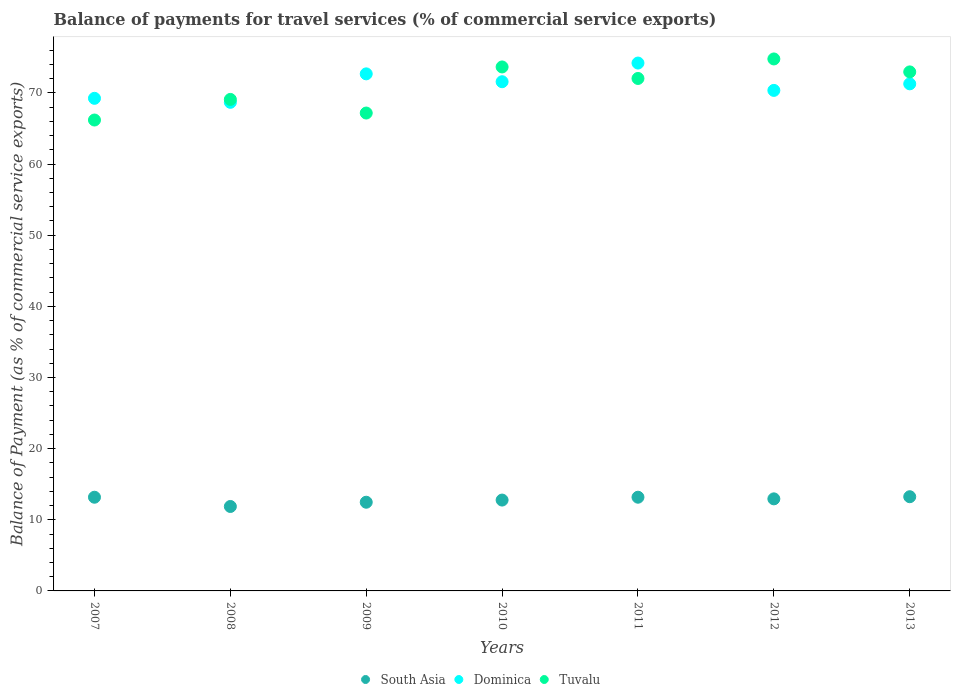How many different coloured dotlines are there?
Offer a very short reply. 3. Is the number of dotlines equal to the number of legend labels?
Offer a very short reply. Yes. What is the balance of payments for travel services in Tuvalu in 2010?
Offer a very short reply. 73.65. Across all years, what is the maximum balance of payments for travel services in South Asia?
Give a very brief answer. 13.24. Across all years, what is the minimum balance of payments for travel services in Tuvalu?
Keep it short and to the point. 66.19. In which year was the balance of payments for travel services in South Asia maximum?
Your answer should be compact. 2013. What is the total balance of payments for travel services in Tuvalu in the graph?
Give a very brief answer. 495.86. What is the difference between the balance of payments for travel services in South Asia in 2009 and that in 2013?
Make the answer very short. -0.77. What is the difference between the balance of payments for travel services in Dominica in 2013 and the balance of payments for travel services in Tuvalu in 2009?
Provide a succinct answer. 4.1. What is the average balance of payments for travel services in South Asia per year?
Offer a very short reply. 12.8. In the year 2013, what is the difference between the balance of payments for travel services in South Asia and balance of payments for travel services in Tuvalu?
Your response must be concise. -59.71. What is the ratio of the balance of payments for travel services in South Asia in 2009 to that in 2012?
Offer a terse response. 0.96. Is the balance of payments for travel services in Dominica in 2008 less than that in 2009?
Keep it short and to the point. Yes. What is the difference between the highest and the second highest balance of payments for travel services in South Asia?
Provide a succinct answer. 0.07. What is the difference between the highest and the lowest balance of payments for travel services in South Asia?
Provide a succinct answer. 1.37. Is the sum of the balance of payments for travel services in Tuvalu in 2008 and 2009 greater than the maximum balance of payments for travel services in South Asia across all years?
Your response must be concise. Yes. Is it the case that in every year, the sum of the balance of payments for travel services in Tuvalu and balance of payments for travel services in Dominica  is greater than the balance of payments for travel services in South Asia?
Provide a short and direct response. Yes. Does the balance of payments for travel services in Dominica monotonically increase over the years?
Your response must be concise. No. How many years are there in the graph?
Provide a short and direct response. 7. Are the values on the major ticks of Y-axis written in scientific E-notation?
Provide a short and direct response. No. How many legend labels are there?
Provide a short and direct response. 3. How are the legend labels stacked?
Provide a short and direct response. Horizontal. What is the title of the graph?
Your response must be concise. Balance of payments for travel services (% of commercial service exports). Does "Fragile and conflict affected situations" appear as one of the legend labels in the graph?
Provide a short and direct response. No. What is the label or title of the Y-axis?
Offer a very short reply. Balance of Payment (as % of commercial service exports). What is the Balance of Payment (as % of commercial service exports) of South Asia in 2007?
Ensure brevity in your answer.  13.17. What is the Balance of Payment (as % of commercial service exports) of Dominica in 2007?
Your answer should be compact. 69.24. What is the Balance of Payment (as % of commercial service exports) of Tuvalu in 2007?
Offer a very short reply. 66.19. What is the Balance of Payment (as % of commercial service exports) of South Asia in 2008?
Ensure brevity in your answer.  11.87. What is the Balance of Payment (as % of commercial service exports) in Dominica in 2008?
Your answer should be very brief. 68.68. What is the Balance of Payment (as % of commercial service exports) in Tuvalu in 2008?
Your response must be concise. 69.09. What is the Balance of Payment (as % of commercial service exports) in South Asia in 2009?
Ensure brevity in your answer.  12.47. What is the Balance of Payment (as % of commercial service exports) in Dominica in 2009?
Your answer should be very brief. 72.68. What is the Balance of Payment (as % of commercial service exports) of Tuvalu in 2009?
Ensure brevity in your answer.  67.17. What is the Balance of Payment (as % of commercial service exports) of South Asia in 2010?
Make the answer very short. 12.77. What is the Balance of Payment (as % of commercial service exports) in Dominica in 2010?
Make the answer very short. 71.57. What is the Balance of Payment (as % of commercial service exports) in Tuvalu in 2010?
Keep it short and to the point. 73.65. What is the Balance of Payment (as % of commercial service exports) of South Asia in 2011?
Provide a short and direct response. 13.17. What is the Balance of Payment (as % of commercial service exports) of Dominica in 2011?
Provide a succinct answer. 74.2. What is the Balance of Payment (as % of commercial service exports) of Tuvalu in 2011?
Provide a succinct answer. 72.03. What is the Balance of Payment (as % of commercial service exports) in South Asia in 2012?
Provide a succinct answer. 12.94. What is the Balance of Payment (as % of commercial service exports) of Dominica in 2012?
Your response must be concise. 70.36. What is the Balance of Payment (as % of commercial service exports) of Tuvalu in 2012?
Ensure brevity in your answer.  74.77. What is the Balance of Payment (as % of commercial service exports) in South Asia in 2013?
Your answer should be very brief. 13.24. What is the Balance of Payment (as % of commercial service exports) of Dominica in 2013?
Offer a terse response. 71.28. What is the Balance of Payment (as % of commercial service exports) of Tuvalu in 2013?
Your answer should be compact. 72.96. Across all years, what is the maximum Balance of Payment (as % of commercial service exports) in South Asia?
Provide a short and direct response. 13.24. Across all years, what is the maximum Balance of Payment (as % of commercial service exports) of Dominica?
Your answer should be very brief. 74.2. Across all years, what is the maximum Balance of Payment (as % of commercial service exports) in Tuvalu?
Your response must be concise. 74.77. Across all years, what is the minimum Balance of Payment (as % of commercial service exports) in South Asia?
Provide a succinct answer. 11.87. Across all years, what is the minimum Balance of Payment (as % of commercial service exports) in Dominica?
Keep it short and to the point. 68.68. Across all years, what is the minimum Balance of Payment (as % of commercial service exports) in Tuvalu?
Keep it short and to the point. 66.19. What is the total Balance of Payment (as % of commercial service exports) in South Asia in the graph?
Provide a short and direct response. 89.63. What is the total Balance of Payment (as % of commercial service exports) of Dominica in the graph?
Provide a short and direct response. 498. What is the total Balance of Payment (as % of commercial service exports) of Tuvalu in the graph?
Provide a succinct answer. 495.86. What is the difference between the Balance of Payment (as % of commercial service exports) of South Asia in 2007 and that in 2008?
Ensure brevity in your answer.  1.3. What is the difference between the Balance of Payment (as % of commercial service exports) of Dominica in 2007 and that in 2008?
Ensure brevity in your answer.  0.56. What is the difference between the Balance of Payment (as % of commercial service exports) of Tuvalu in 2007 and that in 2008?
Offer a terse response. -2.9. What is the difference between the Balance of Payment (as % of commercial service exports) in South Asia in 2007 and that in 2009?
Your answer should be compact. 0.7. What is the difference between the Balance of Payment (as % of commercial service exports) of Dominica in 2007 and that in 2009?
Ensure brevity in your answer.  -3.44. What is the difference between the Balance of Payment (as % of commercial service exports) of Tuvalu in 2007 and that in 2009?
Give a very brief answer. -0.98. What is the difference between the Balance of Payment (as % of commercial service exports) in South Asia in 2007 and that in 2010?
Make the answer very short. 0.4. What is the difference between the Balance of Payment (as % of commercial service exports) in Dominica in 2007 and that in 2010?
Your answer should be very brief. -2.33. What is the difference between the Balance of Payment (as % of commercial service exports) of Tuvalu in 2007 and that in 2010?
Provide a succinct answer. -7.46. What is the difference between the Balance of Payment (as % of commercial service exports) in South Asia in 2007 and that in 2011?
Make the answer very short. -0. What is the difference between the Balance of Payment (as % of commercial service exports) of Dominica in 2007 and that in 2011?
Your answer should be very brief. -4.96. What is the difference between the Balance of Payment (as % of commercial service exports) in Tuvalu in 2007 and that in 2011?
Give a very brief answer. -5.84. What is the difference between the Balance of Payment (as % of commercial service exports) of South Asia in 2007 and that in 2012?
Your answer should be very brief. 0.23. What is the difference between the Balance of Payment (as % of commercial service exports) in Dominica in 2007 and that in 2012?
Give a very brief answer. -1.11. What is the difference between the Balance of Payment (as % of commercial service exports) of Tuvalu in 2007 and that in 2012?
Make the answer very short. -8.58. What is the difference between the Balance of Payment (as % of commercial service exports) of South Asia in 2007 and that in 2013?
Your response must be concise. -0.07. What is the difference between the Balance of Payment (as % of commercial service exports) in Dominica in 2007 and that in 2013?
Keep it short and to the point. -2.04. What is the difference between the Balance of Payment (as % of commercial service exports) in Tuvalu in 2007 and that in 2013?
Provide a short and direct response. -6.77. What is the difference between the Balance of Payment (as % of commercial service exports) in South Asia in 2008 and that in 2009?
Keep it short and to the point. -0.6. What is the difference between the Balance of Payment (as % of commercial service exports) of Dominica in 2008 and that in 2009?
Ensure brevity in your answer.  -4. What is the difference between the Balance of Payment (as % of commercial service exports) of Tuvalu in 2008 and that in 2009?
Keep it short and to the point. 1.92. What is the difference between the Balance of Payment (as % of commercial service exports) of South Asia in 2008 and that in 2010?
Your response must be concise. -0.9. What is the difference between the Balance of Payment (as % of commercial service exports) of Dominica in 2008 and that in 2010?
Your response must be concise. -2.9. What is the difference between the Balance of Payment (as % of commercial service exports) in Tuvalu in 2008 and that in 2010?
Provide a succinct answer. -4.56. What is the difference between the Balance of Payment (as % of commercial service exports) in South Asia in 2008 and that in 2011?
Your answer should be compact. -1.3. What is the difference between the Balance of Payment (as % of commercial service exports) of Dominica in 2008 and that in 2011?
Provide a succinct answer. -5.52. What is the difference between the Balance of Payment (as % of commercial service exports) in Tuvalu in 2008 and that in 2011?
Offer a terse response. -2.95. What is the difference between the Balance of Payment (as % of commercial service exports) in South Asia in 2008 and that in 2012?
Your response must be concise. -1.07. What is the difference between the Balance of Payment (as % of commercial service exports) in Dominica in 2008 and that in 2012?
Provide a short and direct response. -1.68. What is the difference between the Balance of Payment (as % of commercial service exports) in Tuvalu in 2008 and that in 2012?
Give a very brief answer. -5.69. What is the difference between the Balance of Payment (as % of commercial service exports) of South Asia in 2008 and that in 2013?
Make the answer very short. -1.37. What is the difference between the Balance of Payment (as % of commercial service exports) of Dominica in 2008 and that in 2013?
Ensure brevity in your answer.  -2.6. What is the difference between the Balance of Payment (as % of commercial service exports) of Tuvalu in 2008 and that in 2013?
Give a very brief answer. -3.87. What is the difference between the Balance of Payment (as % of commercial service exports) in South Asia in 2009 and that in 2010?
Provide a short and direct response. -0.3. What is the difference between the Balance of Payment (as % of commercial service exports) in Dominica in 2009 and that in 2010?
Provide a succinct answer. 1.1. What is the difference between the Balance of Payment (as % of commercial service exports) in Tuvalu in 2009 and that in 2010?
Provide a succinct answer. -6.48. What is the difference between the Balance of Payment (as % of commercial service exports) of South Asia in 2009 and that in 2011?
Provide a short and direct response. -0.7. What is the difference between the Balance of Payment (as % of commercial service exports) of Dominica in 2009 and that in 2011?
Offer a terse response. -1.52. What is the difference between the Balance of Payment (as % of commercial service exports) in Tuvalu in 2009 and that in 2011?
Keep it short and to the point. -4.86. What is the difference between the Balance of Payment (as % of commercial service exports) in South Asia in 2009 and that in 2012?
Offer a terse response. -0.47. What is the difference between the Balance of Payment (as % of commercial service exports) of Dominica in 2009 and that in 2012?
Your answer should be very brief. 2.32. What is the difference between the Balance of Payment (as % of commercial service exports) of Tuvalu in 2009 and that in 2012?
Provide a succinct answer. -7.6. What is the difference between the Balance of Payment (as % of commercial service exports) of South Asia in 2009 and that in 2013?
Ensure brevity in your answer.  -0.77. What is the difference between the Balance of Payment (as % of commercial service exports) of Dominica in 2009 and that in 2013?
Your response must be concise. 1.4. What is the difference between the Balance of Payment (as % of commercial service exports) of Tuvalu in 2009 and that in 2013?
Offer a very short reply. -5.78. What is the difference between the Balance of Payment (as % of commercial service exports) of South Asia in 2010 and that in 2011?
Make the answer very short. -0.4. What is the difference between the Balance of Payment (as % of commercial service exports) of Dominica in 2010 and that in 2011?
Offer a terse response. -2.62. What is the difference between the Balance of Payment (as % of commercial service exports) in Tuvalu in 2010 and that in 2011?
Offer a terse response. 1.62. What is the difference between the Balance of Payment (as % of commercial service exports) in South Asia in 2010 and that in 2012?
Make the answer very short. -0.17. What is the difference between the Balance of Payment (as % of commercial service exports) in Dominica in 2010 and that in 2012?
Offer a very short reply. 1.22. What is the difference between the Balance of Payment (as % of commercial service exports) of Tuvalu in 2010 and that in 2012?
Your response must be concise. -1.12. What is the difference between the Balance of Payment (as % of commercial service exports) of South Asia in 2010 and that in 2013?
Make the answer very short. -0.47. What is the difference between the Balance of Payment (as % of commercial service exports) of Dominica in 2010 and that in 2013?
Keep it short and to the point. 0.3. What is the difference between the Balance of Payment (as % of commercial service exports) in Tuvalu in 2010 and that in 2013?
Provide a succinct answer. 0.69. What is the difference between the Balance of Payment (as % of commercial service exports) of South Asia in 2011 and that in 2012?
Provide a short and direct response. 0.23. What is the difference between the Balance of Payment (as % of commercial service exports) in Dominica in 2011 and that in 2012?
Your answer should be compact. 3.84. What is the difference between the Balance of Payment (as % of commercial service exports) of Tuvalu in 2011 and that in 2012?
Provide a short and direct response. -2.74. What is the difference between the Balance of Payment (as % of commercial service exports) in South Asia in 2011 and that in 2013?
Keep it short and to the point. -0.07. What is the difference between the Balance of Payment (as % of commercial service exports) in Dominica in 2011 and that in 2013?
Provide a succinct answer. 2.92. What is the difference between the Balance of Payment (as % of commercial service exports) in Tuvalu in 2011 and that in 2013?
Your response must be concise. -0.92. What is the difference between the Balance of Payment (as % of commercial service exports) of South Asia in 2012 and that in 2013?
Offer a terse response. -0.3. What is the difference between the Balance of Payment (as % of commercial service exports) of Dominica in 2012 and that in 2013?
Make the answer very short. -0.92. What is the difference between the Balance of Payment (as % of commercial service exports) in Tuvalu in 2012 and that in 2013?
Make the answer very short. 1.82. What is the difference between the Balance of Payment (as % of commercial service exports) of South Asia in 2007 and the Balance of Payment (as % of commercial service exports) of Dominica in 2008?
Offer a very short reply. -55.51. What is the difference between the Balance of Payment (as % of commercial service exports) of South Asia in 2007 and the Balance of Payment (as % of commercial service exports) of Tuvalu in 2008?
Make the answer very short. -55.92. What is the difference between the Balance of Payment (as % of commercial service exports) of Dominica in 2007 and the Balance of Payment (as % of commercial service exports) of Tuvalu in 2008?
Give a very brief answer. 0.15. What is the difference between the Balance of Payment (as % of commercial service exports) of South Asia in 2007 and the Balance of Payment (as % of commercial service exports) of Dominica in 2009?
Offer a very short reply. -59.51. What is the difference between the Balance of Payment (as % of commercial service exports) of South Asia in 2007 and the Balance of Payment (as % of commercial service exports) of Tuvalu in 2009?
Your answer should be compact. -54. What is the difference between the Balance of Payment (as % of commercial service exports) of Dominica in 2007 and the Balance of Payment (as % of commercial service exports) of Tuvalu in 2009?
Give a very brief answer. 2.07. What is the difference between the Balance of Payment (as % of commercial service exports) in South Asia in 2007 and the Balance of Payment (as % of commercial service exports) in Dominica in 2010?
Your response must be concise. -58.4. What is the difference between the Balance of Payment (as % of commercial service exports) in South Asia in 2007 and the Balance of Payment (as % of commercial service exports) in Tuvalu in 2010?
Ensure brevity in your answer.  -60.48. What is the difference between the Balance of Payment (as % of commercial service exports) in Dominica in 2007 and the Balance of Payment (as % of commercial service exports) in Tuvalu in 2010?
Your response must be concise. -4.41. What is the difference between the Balance of Payment (as % of commercial service exports) in South Asia in 2007 and the Balance of Payment (as % of commercial service exports) in Dominica in 2011?
Make the answer very short. -61.03. What is the difference between the Balance of Payment (as % of commercial service exports) of South Asia in 2007 and the Balance of Payment (as % of commercial service exports) of Tuvalu in 2011?
Your answer should be compact. -58.86. What is the difference between the Balance of Payment (as % of commercial service exports) of Dominica in 2007 and the Balance of Payment (as % of commercial service exports) of Tuvalu in 2011?
Keep it short and to the point. -2.79. What is the difference between the Balance of Payment (as % of commercial service exports) in South Asia in 2007 and the Balance of Payment (as % of commercial service exports) in Dominica in 2012?
Give a very brief answer. -57.19. What is the difference between the Balance of Payment (as % of commercial service exports) in South Asia in 2007 and the Balance of Payment (as % of commercial service exports) in Tuvalu in 2012?
Make the answer very short. -61.61. What is the difference between the Balance of Payment (as % of commercial service exports) in Dominica in 2007 and the Balance of Payment (as % of commercial service exports) in Tuvalu in 2012?
Keep it short and to the point. -5.53. What is the difference between the Balance of Payment (as % of commercial service exports) of South Asia in 2007 and the Balance of Payment (as % of commercial service exports) of Dominica in 2013?
Offer a very short reply. -58.11. What is the difference between the Balance of Payment (as % of commercial service exports) of South Asia in 2007 and the Balance of Payment (as % of commercial service exports) of Tuvalu in 2013?
Offer a very short reply. -59.79. What is the difference between the Balance of Payment (as % of commercial service exports) of Dominica in 2007 and the Balance of Payment (as % of commercial service exports) of Tuvalu in 2013?
Your answer should be compact. -3.71. What is the difference between the Balance of Payment (as % of commercial service exports) in South Asia in 2008 and the Balance of Payment (as % of commercial service exports) in Dominica in 2009?
Your answer should be compact. -60.81. What is the difference between the Balance of Payment (as % of commercial service exports) of South Asia in 2008 and the Balance of Payment (as % of commercial service exports) of Tuvalu in 2009?
Your answer should be compact. -55.3. What is the difference between the Balance of Payment (as % of commercial service exports) in Dominica in 2008 and the Balance of Payment (as % of commercial service exports) in Tuvalu in 2009?
Offer a very short reply. 1.51. What is the difference between the Balance of Payment (as % of commercial service exports) in South Asia in 2008 and the Balance of Payment (as % of commercial service exports) in Dominica in 2010?
Offer a very short reply. -59.71. What is the difference between the Balance of Payment (as % of commercial service exports) of South Asia in 2008 and the Balance of Payment (as % of commercial service exports) of Tuvalu in 2010?
Keep it short and to the point. -61.78. What is the difference between the Balance of Payment (as % of commercial service exports) in Dominica in 2008 and the Balance of Payment (as % of commercial service exports) in Tuvalu in 2010?
Your answer should be compact. -4.97. What is the difference between the Balance of Payment (as % of commercial service exports) in South Asia in 2008 and the Balance of Payment (as % of commercial service exports) in Dominica in 2011?
Keep it short and to the point. -62.33. What is the difference between the Balance of Payment (as % of commercial service exports) in South Asia in 2008 and the Balance of Payment (as % of commercial service exports) in Tuvalu in 2011?
Your answer should be compact. -60.16. What is the difference between the Balance of Payment (as % of commercial service exports) in Dominica in 2008 and the Balance of Payment (as % of commercial service exports) in Tuvalu in 2011?
Offer a very short reply. -3.35. What is the difference between the Balance of Payment (as % of commercial service exports) in South Asia in 2008 and the Balance of Payment (as % of commercial service exports) in Dominica in 2012?
Keep it short and to the point. -58.49. What is the difference between the Balance of Payment (as % of commercial service exports) in South Asia in 2008 and the Balance of Payment (as % of commercial service exports) in Tuvalu in 2012?
Your answer should be very brief. -62.91. What is the difference between the Balance of Payment (as % of commercial service exports) of Dominica in 2008 and the Balance of Payment (as % of commercial service exports) of Tuvalu in 2012?
Ensure brevity in your answer.  -6.1. What is the difference between the Balance of Payment (as % of commercial service exports) of South Asia in 2008 and the Balance of Payment (as % of commercial service exports) of Dominica in 2013?
Offer a very short reply. -59.41. What is the difference between the Balance of Payment (as % of commercial service exports) in South Asia in 2008 and the Balance of Payment (as % of commercial service exports) in Tuvalu in 2013?
Offer a terse response. -61.09. What is the difference between the Balance of Payment (as % of commercial service exports) in Dominica in 2008 and the Balance of Payment (as % of commercial service exports) in Tuvalu in 2013?
Your answer should be very brief. -4.28. What is the difference between the Balance of Payment (as % of commercial service exports) in South Asia in 2009 and the Balance of Payment (as % of commercial service exports) in Dominica in 2010?
Your answer should be compact. -59.11. What is the difference between the Balance of Payment (as % of commercial service exports) in South Asia in 2009 and the Balance of Payment (as % of commercial service exports) in Tuvalu in 2010?
Your answer should be very brief. -61.18. What is the difference between the Balance of Payment (as % of commercial service exports) of Dominica in 2009 and the Balance of Payment (as % of commercial service exports) of Tuvalu in 2010?
Your answer should be compact. -0.97. What is the difference between the Balance of Payment (as % of commercial service exports) of South Asia in 2009 and the Balance of Payment (as % of commercial service exports) of Dominica in 2011?
Your answer should be compact. -61.73. What is the difference between the Balance of Payment (as % of commercial service exports) in South Asia in 2009 and the Balance of Payment (as % of commercial service exports) in Tuvalu in 2011?
Provide a succinct answer. -59.57. What is the difference between the Balance of Payment (as % of commercial service exports) in Dominica in 2009 and the Balance of Payment (as % of commercial service exports) in Tuvalu in 2011?
Your answer should be very brief. 0.65. What is the difference between the Balance of Payment (as % of commercial service exports) of South Asia in 2009 and the Balance of Payment (as % of commercial service exports) of Dominica in 2012?
Keep it short and to the point. -57.89. What is the difference between the Balance of Payment (as % of commercial service exports) of South Asia in 2009 and the Balance of Payment (as % of commercial service exports) of Tuvalu in 2012?
Offer a terse response. -62.31. What is the difference between the Balance of Payment (as % of commercial service exports) in Dominica in 2009 and the Balance of Payment (as % of commercial service exports) in Tuvalu in 2012?
Ensure brevity in your answer.  -2.1. What is the difference between the Balance of Payment (as % of commercial service exports) of South Asia in 2009 and the Balance of Payment (as % of commercial service exports) of Dominica in 2013?
Give a very brief answer. -58.81. What is the difference between the Balance of Payment (as % of commercial service exports) in South Asia in 2009 and the Balance of Payment (as % of commercial service exports) in Tuvalu in 2013?
Provide a short and direct response. -60.49. What is the difference between the Balance of Payment (as % of commercial service exports) of Dominica in 2009 and the Balance of Payment (as % of commercial service exports) of Tuvalu in 2013?
Make the answer very short. -0.28. What is the difference between the Balance of Payment (as % of commercial service exports) in South Asia in 2010 and the Balance of Payment (as % of commercial service exports) in Dominica in 2011?
Your answer should be very brief. -61.43. What is the difference between the Balance of Payment (as % of commercial service exports) of South Asia in 2010 and the Balance of Payment (as % of commercial service exports) of Tuvalu in 2011?
Provide a short and direct response. -59.26. What is the difference between the Balance of Payment (as % of commercial service exports) in Dominica in 2010 and the Balance of Payment (as % of commercial service exports) in Tuvalu in 2011?
Your answer should be very brief. -0.46. What is the difference between the Balance of Payment (as % of commercial service exports) in South Asia in 2010 and the Balance of Payment (as % of commercial service exports) in Dominica in 2012?
Offer a terse response. -57.58. What is the difference between the Balance of Payment (as % of commercial service exports) of South Asia in 2010 and the Balance of Payment (as % of commercial service exports) of Tuvalu in 2012?
Your response must be concise. -62. What is the difference between the Balance of Payment (as % of commercial service exports) of Dominica in 2010 and the Balance of Payment (as % of commercial service exports) of Tuvalu in 2012?
Your answer should be very brief. -3.2. What is the difference between the Balance of Payment (as % of commercial service exports) of South Asia in 2010 and the Balance of Payment (as % of commercial service exports) of Dominica in 2013?
Provide a succinct answer. -58.5. What is the difference between the Balance of Payment (as % of commercial service exports) in South Asia in 2010 and the Balance of Payment (as % of commercial service exports) in Tuvalu in 2013?
Offer a very short reply. -60.18. What is the difference between the Balance of Payment (as % of commercial service exports) in Dominica in 2010 and the Balance of Payment (as % of commercial service exports) in Tuvalu in 2013?
Offer a very short reply. -1.38. What is the difference between the Balance of Payment (as % of commercial service exports) of South Asia in 2011 and the Balance of Payment (as % of commercial service exports) of Dominica in 2012?
Offer a very short reply. -57.18. What is the difference between the Balance of Payment (as % of commercial service exports) of South Asia in 2011 and the Balance of Payment (as % of commercial service exports) of Tuvalu in 2012?
Keep it short and to the point. -61.6. What is the difference between the Balance of Payment (as % of commercial service exports) in Dominica in 2011 and the Balance of Payment (as % of commercial service exports) in Tuvalu in 2012?
Ensure brevity in your answer.  -0.58. What is the difference between the Balance of Payment (as % of commercial service exports) of South Asia in 2011 and the Balance of Payment (as % of commercial service exports) of Dominica in 2013?
Your answer should be very brief. -58.1. What is the difference between the Balance of Payment (as % of commercial service exports) in South Asia in 2011 and the Balance of Payment (as % of commercial service exports) in Tuvalu in 2013?
Make the answer very short. -59.78. What is the difference between the Balance of Payment (as % of commercial service exports) of Dominica in 2011 and the Balance of Payment (as % of commercial service exports) of Tuvalu in 2013?
Provide a succinct answer. 1.24. What is the difference between the Balance of Payment (as % of commercial service exports) in South Asia in 2012 and the Balance of Payment (as % of commercial service exports) in Dominica in 2013?
Ensure brevity in your answer.  -58.34. What is the difference between the Balance of Payment (as % of commercial service exports) of South Asia in 2012 and the Balance of Payment (as % of commercial service exports) of Tuvalu in 2013?
Give a very brief answer. -60.01. What is the difference between the Balance of Payment (as % of commercial service exports) of Dominica in 2012 and the Balance of Payment (as % of commercial service exports) of Tuvalu in 2013?
Your response must be concise. -2.6. What is the average Balance of Payment (as % of commercial service exports) of South Asia per year?
Your answer should be compact. 12.8. What is the average Balance of Payment (as % of commercial service exports) in Dominica per year?
Keep it short and to the point. 71.14. What is the average Balance of Payment (as % of commercial service exports) of Tuvalu per year?
Offer a very short reply. 70.84. In the year 2007, what is the difference between the Balance of Payment (as % of commercial service exports) of South Asia and Balance of Payment (as % of commercial service exports) of Dominica?
Your response must be concise. -56.07. In the year 2007, what is the difference between the Balance of Payment (as % of commercial service exports) of South Asia and Balance of Payment (as % of commercial service exports) of Tuvalu?
Provide a short and direct response. -53.02. In the year 2007, what is the difference between the Balance of Payment (as % of commercial service exports) of Dominica and Balance of Payment (as % of commercial service exports) of Tuvalu?
Offer a terse response. 3.05. In the year 2008, what is the difference between the Balance of Payment (as % of commercial service exports) of South Asia and Balance of Payment (as % of commercial service exports) of Dominica?
Make the answer very short. -56.81. In the year 2008, what is the difference between the Balance of Payment (as % of commercial service exports) of South Asia and Balance of Payment (as % of commercial service exports) of Tuvalu?
Your answer should be very brief. -57.22. In the year 2008, what is the difference between the Balance of Payment (as % of commercial service exports) in Dominica and Balance of Payment (as % of commercial service exports) in Tuvalu?
Provide a succinct answer. -0.41. In the year 2009, what is the difference between the Balance of Payment (as % of commercial service exports) in South Asia and Balance of Payment (as % of commercial service exports) in Dominica?
Your answer should be very brief. -60.21. In the year 2009, what is the difference between the Balance of Payment (as % of commercial service exports) in South Asia and Balance of Payment (as % of commercial service exports) in Tuvalu?
Offer a very short reply. -54.71. In the year 2009, what is the difference between the Balance of Payment (as % of commercial service exports) in Dominica and Balance of Payment (as % of commercial service exports) in Tuvalu?
Make the answer very short. 5.51. In the year 2010, what is the difference between the Balance of Payment (as % of commercial service exports) of South Asia and Balance of Payment (as % of commercial service exports) of Dominica?
Provide a succinct answer. -58.8. In the year 2010, what is the difference between the Balance of Payment (as % of commercial service exports) of South Asia and Balance of Payment (as % of commercial service exports) of Tuvalu?
Keep it short and to the point. -60.88. In the year 2010, what is the difference between the Balance of Payment (as % of commercial service exports) in Dominica and Balance of Payment (as % of commercial service exports) in Tuvalu?
Make the answer very short. -2.08. In the year 2011, what is the difference between the Balance of Payment (as % of commercial service exports) of South Asia and Balance of Payment (as % of commercial service exports) of Dominica?
Your answer should be compact. -61.03. In the year 2011, what is the difference between the Balance of Payment (as % of commercial service exports) in South Asia and Balance of Payment (as % of commercial service exports) in Tuvalu?
Ensure brevity in your answer.  -58.86. In the year 2011, what is the difference between the Balance of Payment (as % of commercial service exports) in Dominica and Balance of Payment (as % of commercial service exports) in Tuvalu?
Provide a succinct answer. 2.17. In the year 2012, what is the difference between the Balance of Payment (as % of commercial service exports) in South Asia and Balance of Payment (as % of commercial service exports) in Dominica?
Keep it short and to the point. -57.41. In the year 2012, what is the difference between the Balance of Payment (as % of commercial service exports) of South Asia and Balance of Payment (as % of commercial service exports) of Tuvalu?
Provide a succinct answer. -61.83. In the year 2012, what is the difference between the Balance of Payment (as % of commercial service exports) in Dominica and Balance of Payment (as % of commercial service exports) in Tuvalu?
Ensure brevity in your answer.  -4.42. In the year 2013, what is the difference between the Balance of Payment (as % of commercial service exports) of South Asia and Balance of Payment (as % of commercial service exports) of Dominica?
Your answer should be very brief. -58.03. In the year 2013, what is the difference between the Balance of Payment (as % of commercial service exports) in South Asia and Balance of Payment (as % of commercial service exports) in Tuvalu?
Offer a very short reply. -59.71. In the year 2013, what is the difference between the Balance of Payment (as % of commercial service exports) in Dominica and Balance of Payment (as % of commercial service exports) in Tuvalu?
Offer a very short reply. -1.68. What is the ratio of the Balance of Payment (as % of commercial service exports) of South Asia in 2007 to that in 2008?
Make the answer very short. 1.11. What is the ratio of the Balance of Payment (as % of commercial service exports) in Dominica in 2007 to that in 2008?
Keep it short and to the point. 1.01. What is the ratio of the Balance of Payment (as % of commercial service exports) in Tuvalu in 2007 to that in 2008?
Your response must be concise. 0.96. What is the ratio of the Balance of Payment (as % of commercial service exports) in South Asia in 2007 to that in 2009?
Make the answer very short. 1.06. What is the ratio of the Balance of Payment (as % of commercial service exports) of Dominica in 2007 to that in 2009?
Provide a short and direct response. 0.95. What is the ratio of the Balance of Payment (as % of commercial service exports) in Tuvalu in 2007 to that in 2009?
Provide a succinct answer. 0.99. What is the ratio of the Balance of Payment (as % of commercial service exports) in South Asia in 2007 to that in 2010?
Make the answer very short. 1.03. What is the ratio of the Balance of Payment (as % of commercial service exports) of Dominica in 2007 to that in 2010?
Your response must be concise. 0.97. What is the ratio of the Balance of Payment (as % of commercial service exports) in Tuvalu in 2007 to that in 2010?
Provide a short and direct response. 0.9. What is the ratio of the Balance of Payment (as % of commercial service exports) of Dominica in 2007 to that in 2011?
Offer a terse response. 0.93. What is the ratio of the Balance of Payment (as % of commercial service exports) in Tuvalu in 2007 to that in 2011?
Provide a short and direct response. 0.92. What is the ratio of the Balance of Payment (as % of commercial service exports) in South Asia in 2007 to that in 2012?
Your answer should be compact. 1.02. What is the ratio of the Balance of Payment (as % of commercial service exports) in Dominica in 2007 to that in 2012?
Keep it short and to the point. 0.98. What is the ratio of the Balance of Payment (as % of commercial service exports) of Tuvalu in 2007 to that in 2012?
Give a very brief answer. 0.89. What is the ratio of the Balance of Payment (as % of commercial service exports) in South Asia in 2007 to that in 2013?
Make the answer very short. 0.99. What is the ratio of the Balance of Payment (as % of commercial service exports) in Dominica in 2007 to that in 2013?
Your response must be concise. 0.97. What is the ratio of the Balance of Payment (as % of commercial service exports) of Tuvalu in 2007 to that in 2013?
Your response must be concise. 0.91. What is the ratio of the Balance of Payment (as % of commercial service exports) in Dominica in 2008 to that in 2009?
Provide a short and direct response. 0.94. What is the ratio of the Balance of Payment (as % of commercial service exports) of Tuvalu in 2008 to that in 2009?
Your response must be concise. 1.03. What is the ratio of the Balance of Payment (as % of commercial service exports) in South Asia in 2008 to that in 2010?
Make the answer very short. 0.93. What is the ratio of the Balance of Payment (as % of commercial service exports) in Dominica in 2008 to that in 2010?
Keep it short and to the point. 0.96. What is the ratio of the Balance of Payment (as % of commercial service exports) in Tuvalu in 2008 to that in 2010?
Make the answer very short. 0.94. What is the ratio of the Balance of Payment (as % of commercial service exports) of South Asia in 2008 to that in 2011?
Offer a terse response. 0.9. What is the ratio of the Balance of Payment (as % of commercial service exports) in Dominica in 2008 to that in 2011?
Make the answer very short. 0.93. What is the ratio of the Balance of Payment (as % of commercial service exports) of Tuvalu in 2008 to that in 2011?
Your response must be concise. 0.96. What is the ratio of the Balance of Payment (as % of commercial service exports) of South Asia in 2008 to that in 2012?
Your answer should be compact. 0.92. What is the ratio of the Balance of Payment (as % of commercial service exports) in Dominica in 2008 to that in 2012?
Your answer should be compact. 0.98. What is the ratio of the Balance of Payment (as % of commercial service exports) in Tuvalu in 2008 to that in 2012?
Offer a terse response. 0.92. What is the ratio of the Balance of Payment (as % of commercial service exports) of South Asia in 2008 to that in 2013?
Keep it short and to the point. 0.9. What is the ratio of the Balance of Payment (as % of commercial service exports) of Dominica in 2008 to that in 2013?
Your answer should be very brief. 0.96. What is the ratio of the Balance of Payment (as % of commercial service exports) of Tuvalu in 2008 to that in 2013?
Give a very brief answer. 0.95. What is the ratio of the Balance of Payment (as % of commercial service exports) of South Asia in 2009 to that in 2010?
Your answer should be compact. 0.98. What is the ratio of the Balance of Payment (as % of commercial service exports) of Dominica in 2009 to that in 2010?
Keep it short and to the point. 1.02. What is the ratio of the Balance of Payment (as % of commercial service exports) of Tuvalu in 2009 to that in 2010?
Offer a very short reply. 0.91. What is the ratio of the Balance of Payment (as % of commercial service exports) of South Asia in 2009 to that in 2011?
Offer a terse response. 0.95. What is the ratio of the Balance of Payment (as % of commercial service exports) in Dominica in 2009 to that in 2011?
Your answer should be compact. 0.98. What is the ratio of the Balance of Payment (as % of commercial service exports) in Tuvalu in 2009 to that in 2011?
Provide a succinct answer. 0.93. What is the ratio of the Balance of Payment (as % of commercial service exports) in South Asia in 2009 to that in 2012?
Offer a terse response. 0.96. What is the ratio of the Balance of Payment (as % of commercial service exports) in Dominica in 2009 to that in 2012?
Your response must be concise. 1.03. What is the ratio of the Balance of Payment (as % of commercial service exports) of Tuvalu in 2009 to that in 2012?
Give a very brief answer. 0.9. What is the ratio of the Balance of Payment (as % of commercial service exports) of South Asia in 2009 to that in 2013?
Your answer should be very brief. 0.94. What is the ratio of the Balance of Payment (as % of commercial service exports) of Dominica in 2009 to that in 2013?
Offer a terse response. 1.02. What is the ratio of the Balance of Payment (as % of commercial service exports) in Tuvalu in 2009 to that in 2013?
Your response must be concise. 0.92. What is the ratio of the Balance of Payment (as % of commercial service exports) of South Asia in 2010 to that in 2011?
Provide a short and direct response. 0.97. What is the ratio of the Balance of Payment (as % of commercial service exports) of Dominica in 2010 to that in 2011?
Keep it short and to the point. 0.96. What is the ratio of the Balance of Payment (as % of commercial service exports) in Tuvalu in 2010 to that in 2011?
Your answer should be compact. 1.02. What is the ratio of the Balance of Payment (as % of commercial service exports) of South Asia in 2010 to that in 2012?
Offer a very short reply. 0.99. What is the ratio of the Balance of Payment (as % of commercial service exports) of Dominica in 2010 to that in 2012?
Provide a short and direct response. 1.02. What is the ratio of the Balance of Payment (as % of commercial service exports) of Tuvalu in 2010 to that in 2012?
Offer a terse response. 0.98. What is the ratio of the Balance of Payment (as % of commercial service exports) of South Asia in 2010 to that in 2013?
Give a very brief answer. 0.96. What is the ratio of the Balance of Payment (as % of commercial service exports) in Tuvalu in 2010 to that in 2013?
Provide a short and direct response. 1.01. What is the ratio of the Balance of Payment (as % of commercial service exports) of South Asia in 2011 to that in 2012?
Provide a short and direct response. 1.02. What is the ratio of the Balance of Payment (as % of commercial service exports) in Dominica in 2011 to that in 2012?
Make the answer very short. 1.05. What is the ratio of the Balance of Payment (as % of commercial service exports) in Tuvalu in 2011 to that in 2012?
Provide a short and direct response. 0.96. What is the ratio of the Balance of Payment (as % of commercial service exports) in Dominica in 2011 to that in 2013?
Offer a terse response. 1.04. What is the ratio of the Balance of Payment (as % of commercial service exports) of Tuvalu in 2011 to that in 2013?
Provide a short and direct response. 0.99. What is the ratio of the Balance of Payment (as % of commercial service exports) in South Asia in 2012 to that in 2013?
Provide a short and direct response. 0.98. What is the ratio of the Balance of Payment (as % of commercial service exports) of Dominica in 2012 to that in 2013?
Offer a very short reply. 0.99. What is the ratio of the Balance of Payment (as % of commercial service exports) of Tuvalu in 2012 to that in 2013?
Provide a short and direct response. 1.02. What is the difference between the highest and the second highest Balance of Payment (as % of commercial service exports) of South Asia?
Give a very brief answer. 0.07. What is the difference between the highest and the second highest Balance of Payment (as % of commercial service exports) of Dominica?
Your answer should be very brief. 1.52. What is the difference between the highest and the second highest Balance of Payment (as % of commercial service exports) in Tuvalu?
Your answer should be very brief. 1.12. What is the difference between the highest and the lowest Balance of Payment (as % of commercial service exports) in South Asia?
Keep it short and to the point. 1.37. What is the difference between the highest and the lowest Balance of Payment (as % of commercial service exports) of Dominica?
Offer a very short reply. 5.52. What is the difference between the highest and the lowest Balance of Payment (as % of commercial service exports) in Tuvalu?
Offer a very short reply. 8.58. 